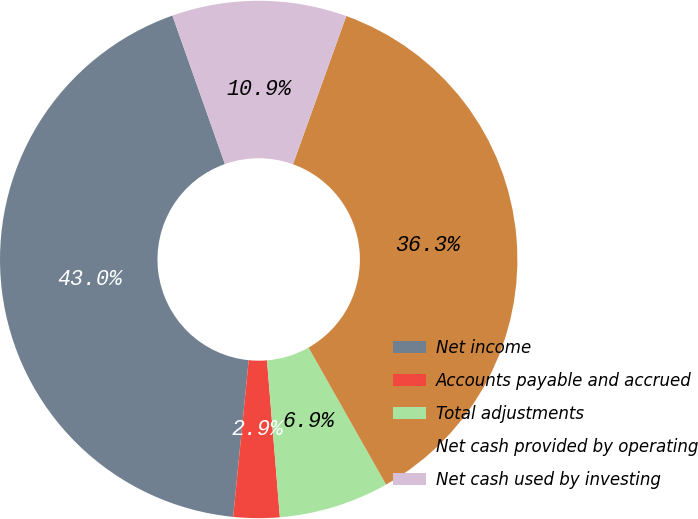Convert chart to OTSL. <chart><loc_0><loc_0><loc_500><loc_500><pie_chart><fcel>Net income<fcel>Accounts payable and accrued<fcel>Total adjustments<fcel>Net cash provided by operating<fcel>Net cash used by investing<nl><fcel>43.02%<fcel>2.88%<fcel>6.89%<fcel>36.31%<fcel>10.91%<nl></chart> 